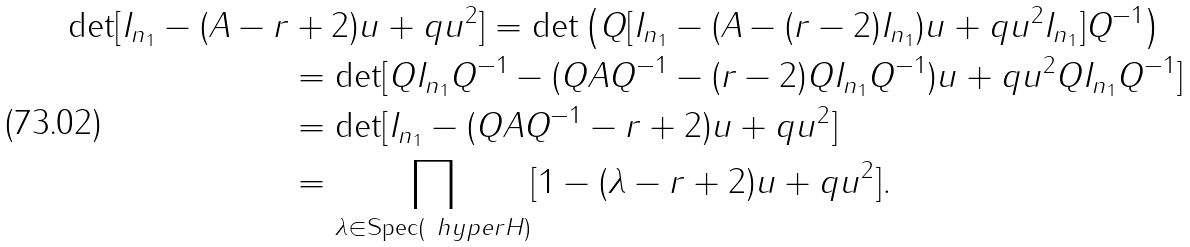<formula> <loc_0><loc_0><loc_500><loc_500>\det [ I _ { n _ { 1 } } - ( A - r & + 2 ) u + q u ^ { 2 } ] = \det \left ( Q [ I _ { n _ { 1 } } - ( A - ( r - 2 ) I _ { n _ { 1 } } ) u + q u ^ { 2 } I _ { n _ { 1 } } ] Q ^ { - 1 } \right ) \\ & = \det [ Q I _ { n _ { 1 } } Q ^ { - 1 } - ( Q A Q ^ { - 1 } - ( r - 2 ) Q I _ { n _ { 1 } } Q ^ { - 1 } ) u + q u ^ { 2 } Q I _ { n _ { 1 } } Q ^ { - 1 } ] \\ & = \det [ I _ { n _ { 1 } } - ( Q A Q ^ { - 1 } - r + 2 ) u + q u ^ { 2 } ] \\ & = \prod _ { \lambda \in \text {Spec} ( \ h y p e r H ) } [ 1 - ( \lambda - r + 2 ) u + q u ^ { 2 } ] .</formula> 